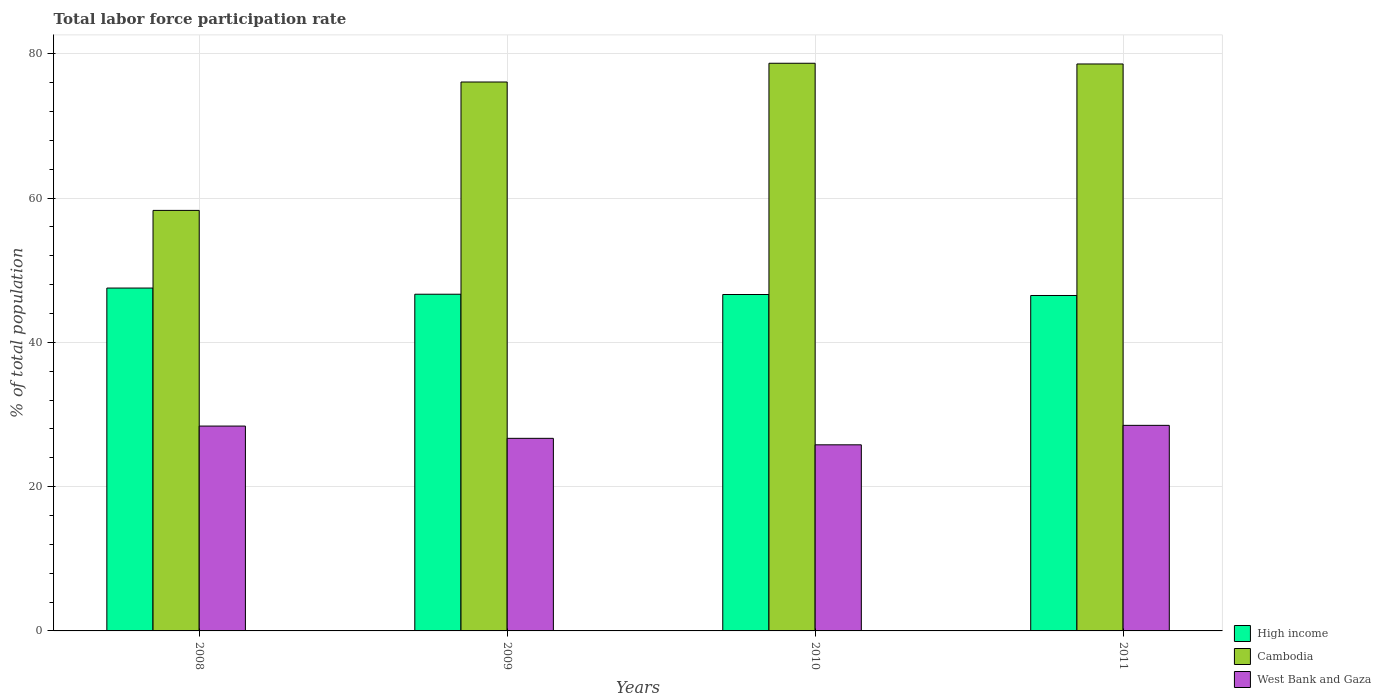Are the number of bars per tick equal to the number of legend labels?
Your answer should be compact. Yes. Are the number of bars on each tick of the X-axis equal?
Your response must be concise. Yes. What is the label of the 1st group of bars from the left?
Provide a short and direct response. 2008. In how many cases, is the number of bars for a given year not equal to the number of legend labels?
Your answer should be compact. 0. What is the total labor force participation rate in West Bank and Gaza in 2009?
Offer a very short reply. 26.7. Across all years, what is the minimum total labor force participation rate in West Bank and Gaza?
Offer a very short reply. 25.8. In which year was the total labor force participation rate in West Bank and Gaza minimum?
Your response must be concise. 2010. What is the total total labor force participation rate in West Bank and Gaza in the graph?
Provide a succinct answer. 109.4. What is the difference between the total labor force participation rate in West Bank and Gaza in 2009 and that in 2011?
Keep it short and to the point. -1.8. What is the difference between the total labor force participation rate in Cambodia in 2008 and the total labor force participation rate in High income in 2010?
Your answer should be very brief. 11.66. What is the average total labor force participation rate in West Bank and Gaza per year?
Ensure brevity in your answer.  27.35. In the year 2010, what is the difference between the total labor force participation rate in High income and total labor force participation rate in West Bank and Gaza?
Offer a terse response. 20.84. In how many years, is the total labor force participation rate in High income greater than 60 %?
Offer a very short reply. 0. What is the ratio of the total labor force participation rate in West Bank and Gaza in 2008 to that in 2009?
Provide a short and direct response. 1.06. What is the difference between the highest and the second highest total labor force participation rate in High income?
Offer a terse response. 0.85. What is the difference between the highest and the lowest total labor force participation rate in High income?
Offer a very short reply. 1.03. Is the sum of the total labor force participation rate in High income in 2008 and 2009 greater than the maximum total labor force participation rate in Cambodia across all years?
Ensure brevity in your answer.  Yes. What does the 2nd bar from the left in 2009 represents?
Give a very brief answer. Cambodia. What does the 2nd bar from the right in 2011 represents?
Your response must be concise. Cambodia. Are all the bars in the graph horizontal?
Provide a succinct answer. No. What is the difference between two consecutive major ticks on the Y-axis?
Provide a short and direct response. 20. Are the values on the major ticks of Y-axis written in scientific E-notation?
Make the answer very short. No. Does the graph contain grids?
Provide a succinct answer. Yes. Where does the legend appear in the graph?
Your response must be concise. Bottom right. What is the title of the graph?
Your answer should be compact. Total labor force participation rate. What is the label or title of the X-axis?
Offer a very short reply. Years. What is the label or title of the Y-axis?
Ensure brevity in your answer.  % of total population. What is the % of total population in High income in 2008?
Keep it short and to the point. 47.53. What is the % of total population of Cambodia in 2008?
Offer a terse response. 58.3. What is the % of total population in West Bank and Gaza in 2008?
Your answer should be very brief. 28.4. What is the % of total population in High income in 2009?
Your response must be concise. 46.68. What is the % of total population in Cambodia in 2009?
Provide a short and direct response. 76.1. What is the % of total population of West Bank and Gaza in 2009?
Provide a succinct answer. 26.7. What is the % of total population in High income in 2010?
Provide a short and direct response. 46.64. What is the % of total population of Cambodia in 2010?
Give a very brief answer. 78.7. What is the % of total population in West Bank and Gaza in 2010?
Your answer should be compact. 25.8. What is the % of total population of High income in 2011?
Ensure brevity in your answer.  46.5. What is the % of total population of Cambodia in 2011?
Make the answer very short. 78.6. Across all years, what is the maximum % of total population of High income?
Give a very brief answer. 47.53. Across all years, what is the maximum % of total population in Cambodia?
Provide a short and direct response. 78.7. Across all years, what is the maximum % of total population in West Bank and Gaza?
Your answer should be very brief. 28.5. Across all years, what is the minimum % of total population of High income?
Provide a succinct answer. 46.5. Across all years, what is the minimum % of total population of Cambodia?
Make the answer very short. 58.3. Across all years, what is the minimum % of total population of West Bank and Gaza?
Your response must be concise. 25.8. What is the total % of total population of High income in the graph?
Your answer should be compact. 187.36. What is the total % of total population of Cambodia in the graph?
Your response must be concise. 291.7. What is the total % of total population in West Bank and Gaza in the graph?
Provide a succinct answer. 109.4. What is the difference between the % of total population in High income in 2008 and that in 2009?
Your response must be concise. 0.85. What is the difference between the % of total population in Cambodia in 2008 and that in 2009?
Provide a succinct answer. -17.8. What is the difference between the % of total population in High income in 2008 and that in 2010?
Keep it short and to the point. 0.89. What is the difference between the % of total population in Cambodia in 2008 and that in 2010?
Your response must be concise. -20.4. What is the difference between the % of total population in High income in 2008 and that in 2011?
Your response must be concise. 1.03. What is the difference between the % of total population in Cambodia in 2008 and that in 2011?
Your response must be concise. -20.3. What is the difference between the % of total population of West Bank and Gaza in 2008 and that in 2011?
Provide a short and direct response. -0.1. What is the difference between the % of total population in High income in 2009 and that in 2010?
Give a very brief answer. 0.04. What is the difference between the % of total population of Cambodia in 2009 and that in 2010?
Ensure brevity in your answer.  -2.6. What is the difference between the % of total population in High income in 2009 and that in 2011?
Your answer should be compact. 0.18. What is the difference between the % of total population of Cambodia in 2009 and that in 2011?
Provide a succinct answer. -2.5. What is the difference between the % of total population in High income in 2010 and that in 2011?
Ensure brevity in your answer.  0.14. What is the difference between the % of total population in Cambodia in 2010 and that in 2011?
Offer a terse response. 0.1. What is the difference between the % of total population of West Bank and Gaza in 2010 and that in 2011?
Offer a very short reply. -2.7. What is the difference between the % of total population of High income in 2008 and the % of total population of Cambodia in 2009?
Your answer should be compact. -28.57. What is the difference between the % of total population of High income in 2008 and the % of total population of West Bank and Gaza in 2009?
Provide a short and direct response. 20.83. What is the difference between the % of total population of Cambodia in 2008 and the % of total population of West Bank and Gaza in 2009?
Give a very brief answer. 31.6. What is the difference between the % of total population of High income in 2008 and the % of total population of Cambodia in 2010?
Give a very brief answer. -31.17. What is the difference between the % of total population in High income in 2008 and the % of total population in West Bank and Gaza in 2010?
Your answer should be very brief. 21.73. What is the difference between the % of total population in Cambodia in 2008 and the % of total population in West Bank and Gaza in 2010?
Offer a terse response. 32.5. What is the difference between the % of total population in High income in 2008 and the % of total population in Cambodia in 2011?
Provide a short and direct response. -31.07. What is the difference between the % of total population in High income in 2008 and the % of total population in West Bank and Gaza in 2011?
Your answer should be compact. 19.03. What is the difference between the % of total population in Cambodia in 2008 and the % of total population in West Bank and Gaza in 2011?
Give a very brief answer. 29.8. What is the difference between the % of total population in High income in 2009 and the % of total population in Cambodia in 2010?
Offer a very short reply. -32.02. What is the difference between the % of total population in High income in 2009 and the % of total population in West Bank and Gaza in 2010?
Offer a very short reply. 20.88. What is the difference between the % of total population in Cambodia in 2009 and the % of total population in West Bank and Gaza in 2010?
Ensure brevity in your answer.  50.3. What is the difference between the % of total population of High income in 2009 and the % of total population of Cambodia in 2011?
Give a very brief answer. -31.92. What is the difference between the % of total population of High income in 2009 and the % of total population of West Bank and Gaza in 2011?
Give a very brief answer. 18.18. What is the difference between the % of total population in Cambodia in 2009 and the % of total population in West Bank and Gaza in 2011?
Provide a short and direct response. 47.6. What is the difference between the % of total population of High income in 2010 and the % of total population of Cambodia in 2011?
Your answer should be compact. -31.96. What is the difference between the % of total population in High income in 2010 and the % of total population in West Bank and Gaza in 2011?
Keep it short and to the point. 18.14. What is the difference between the % of total population of Cambodia in 2010 and the % of total population of West Bank and Gaza in 2011?
Give a very brief answer. 50.2. What is the average % of total population of High income per year?
Offer a terse response. 46.84. What is the average % of total population in Cambodia per year?
Provide a short and direct response. 72.92. What is the average % of total population in West Bank and Gaza per year?
Provide a short and direct response. 27.35. In the year 2008, what is the difference between the % of total population in High income and % of total population in Cambodia?
Give a very brief answer. -10.77. In the year 2008, what is the difference between the % of total population in High income and % of total population in West Bank and Gaza?
Make the answer very short. 19.13. In the year 2008, what is the difference between the % of total population in Cambodia and % of total population in West Bank and Gaza?
Offer a very short reply. 29.9. In the year 2009, what is the difference between the % of total population of High income and % of total population of Cambodia?
Your response must be concise. -29.42. In the year 2009, what is the difference between the % of total population of High income and % of total population of West Bank and Gaza?
Offer a terse response. 19.98. In the year 2009, what is the difference between the % of total population in Cambodia and % of total population in West Bank and Gaza?
Provide a succinct answer. 49.4. In the year 2010, what is the difference between the % of total population in High income and % of total population in Cambodia?
Your answer should be compact. -32.06. In the year 2010, what is the difference between the % of total population of High income and % of total population of West Bank and Gaza?
Provide a succinct answer. 20.84. In the year 2010, what is the difference between the % of total population in Cambodia and % of total population in West Bank and Gaza?
Give a very brief answer. 52.9. In the year 2011, what is the difference between the % of total population of High income and % of total population of Cambodia?
Your answer should be compact. -32.1. In the year 2011, what is the difference between the % of total population of High income and % of total population of West Bank and Gaza?
Your response must be concise. 18. In the year 2011, what is the difference between the % of total population in Cambodia and % of total population in West Bank and Gaza?
Provide a succinct answer. 50.1. What is the ratio of the % of total population of High income in 2008 to that in 2009?
Provide a short and direct response. 1.02. What is the ratio of the % of total population in Cambodia in 2008 to that in 2009?
Ensure brevity in your answer.  0.77. What is the ratio of the % of total population of West Bank and Gaza in 2008 to that in 2009?
Ensure brevity in your answer.  1.06. What is the ratio of the % of total population in High income in 2008 to that in 2010?
Give a very brief answer. 1.02. What is the ratio of the % of total population of Cambodia in 2008 to that in 2010?
Provide a succinct answer. 0.74. What is the ratio of the % of total population in West Bank and Gaza in 2008 to that in 2010?
Give a very brief answer. 1.1. What is the ratio of the % of total population in High income in 2008 to that in 2011?
Your answer should be very brief. 1.02. What is the ratio of the % of total population in Cambodia in 2008 to that in 2011?
Your response must be concise. 0.74. What is the ratio of the % of total population of West Bank and Gaza in 2008 to that in 2011?
Your answer should be compact. 1. What is the ratio of the % of total population in High income in 2009 to that in 2010?
Keep it short and to the point. 1. What is the ratio of the % of total population of West Bank and Gaza in 2009 to that in 2010?
Offer a very short reply. 1.03. What is the ratio of the % of total population in Cambodia in 2009 to that in 2011?
Keep it short and to the point. 0.97. What is the ratio of the % of total population in West Bank and Gaza in 2009 to that in 2011?
Offer a terse response. 0.94. What is the ratio of the % of total population of West Bank and Gaza in 2010 to that in 2011?
Provide a short and direct response. 0.91. What is the difference between the highest and the second highest % of total population in High income?
Keep it short and to the point. 0.85. What is the difference between the highest and the second highest % of total population in Cambodia?
Your answer should be very brief. 0.1. What is the difference between the highest and the lowest % of total population in High income?
Your response must be concise. 1.03. What is the difference between the highest and the lowest % of total population in Cambodia?
Ensure brevity in your answer.  20.4. What is the difference between the highest and the lowest % of total population of West Bank and Gaza?
Provide a succinct answer. 2.7. 